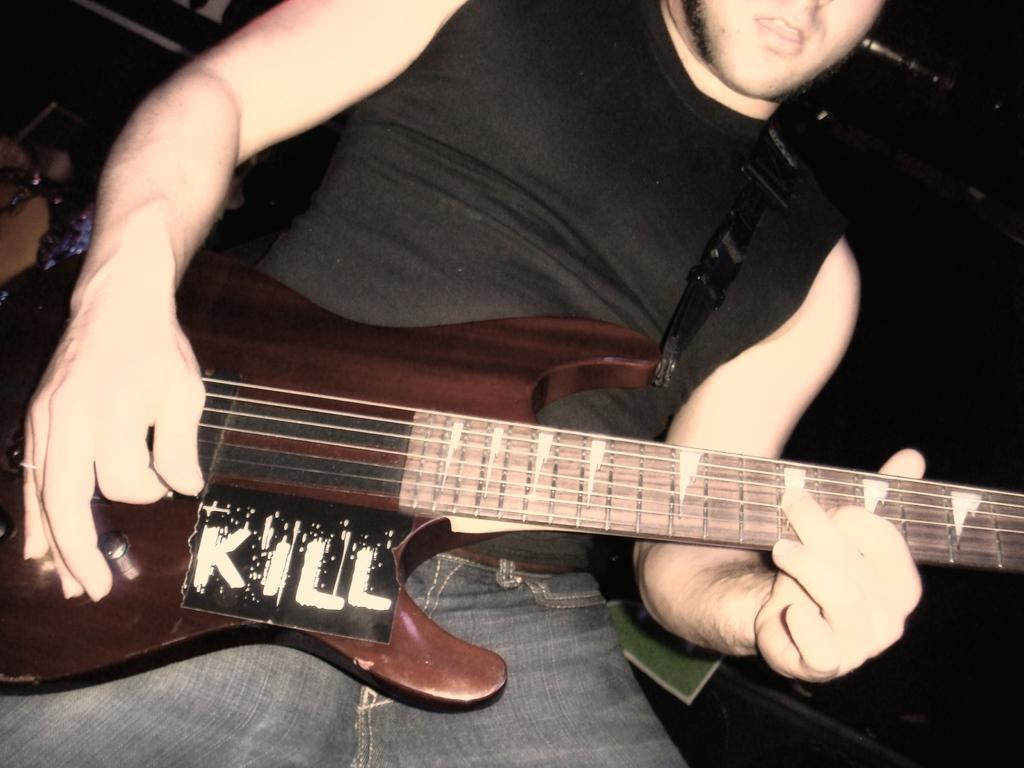In one or two sentences, can you explain what this image depicts? This person playing guitar and wear black color t shirt. 